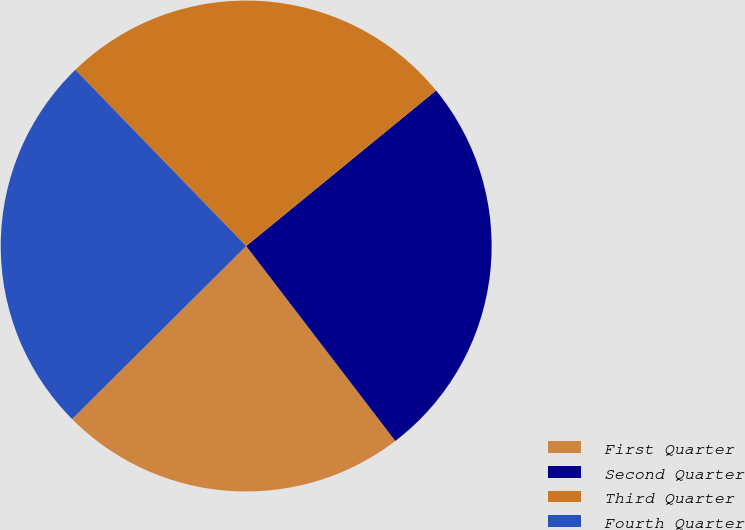Convert chart. <chart><loc_0><loc_0><loc_500><loc_500><pie_chart><fcel>First Quarter<fcel>Second Quarter<fcel>Third Quarter<fcel>Fourth Quarter<nl><fcel>22.94%<fcel>25.53%<fcel>26.33%<fcel>25.2%<nl></chart> 